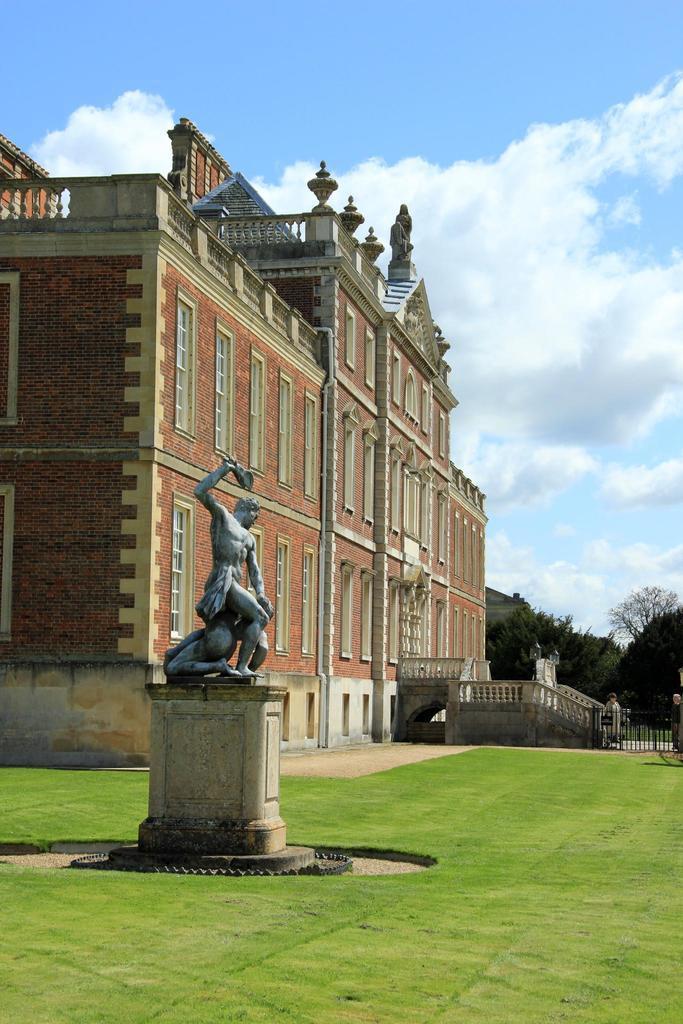Please provide a concise description of this image. In this image I can see the statue which is in grey color. To the side of the statue I can see the building which is in brown color and many windows to it. To the right I can see the railing. In the back there are trees, clouds and the blue sky. 